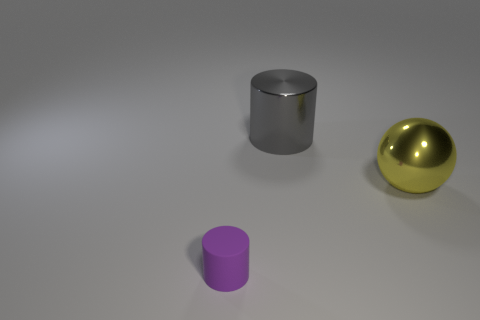What number of other things are there of the same size as the purple matte cylinder?
Your response must be concise. 0. Does the metal object that is in front of the large shiny cylinder have the same size as the metallic object that is on the left side of the big yellow shiny object?
Offer a terse response. Yes. How many things are large metal blocks or objects that are behind the purple matte cylinder?
Offer a very short reply. 2. There is a cylinder behind the purple rubber object; what is its size?
Ensure brevity in your answer.  Large. Is the number of small purple things that are in front of the purple matte cylinder less than the number of tiny purple rubber objects that are behind the yellow thing?
Keep it short and to the point. No. There is a thing that is both behind the tiny purple thing and left of the large metallic ball; what material is it?
Give a very brief answer. Metal. There is a large thing left of the big metallic object to the right of the gray cylinder; what shape is it?
Your answer should be very brief. Cylinder. Does the small cylinder have the same color as the ball?
Offer a very short reply. No. What number of yellow objects are metallic balls or tiny cylinders?
Ensure brevity in your answer.  1. Are there any shiny balls to the left of the gray cylinder?
Give a very brief answer. No. 